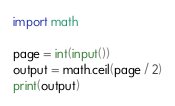Convert code to text. <code><loc_0><loc_0><loc_500><loc_500><_Python_>import math

page = int(input())
output = math.ceil(page / 2)
print(output)</code> 